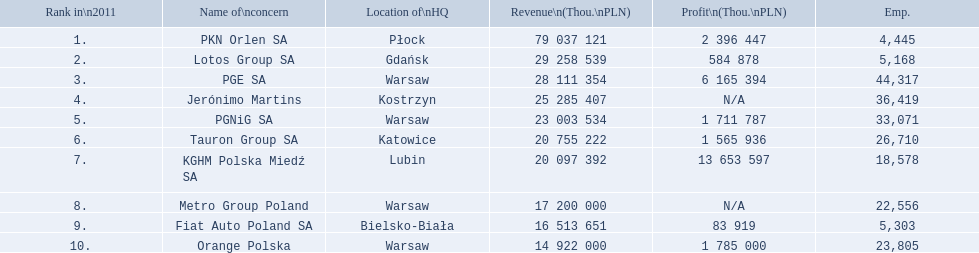What are the names of the major companies of poland? PKN Orlen SA, Lotos Group SA, PGE SA, Jerónimo Martins, PGNiG SA, Tauron Group SA, KGHM Polska Miedź SA, Metro Group Poland, Fiat Auto Poland SA, Orange Polska. What are the revenues of those companies in thou. pln? PKN Orlen SA, 79 037 121, Lotos Group SA, 29 258 539, PGE SA, 28 111 354, Jerónimo Martins, 25 285 407, PGNiG SA, 23 003 534, Tauron Group SA, 20 755 222, KGHM Polska Miedź SA, 20 097 392, Metro Group Poland, 17 200 000, Fiat Auto Poland SA, 16 513 651, Orange Polska, 14 922 000. Which of these revenues is greater than 75 000 000 thou. pln? 79 037 121. Which company has a revenue equal to 79 037 121 thou pln? PKN Orlen SA. 